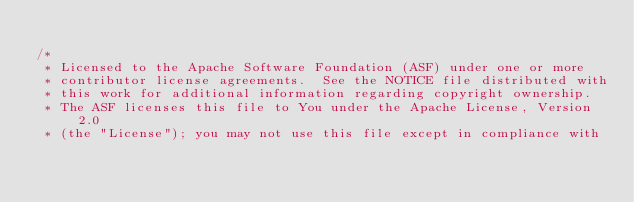<code> <loc_0><loc_0><loc_500><loc_500><_C_>
/*
 * Licensed to the Apache Software Foundation (ASF) under one or more
 * contributor license agreements.  See the NOTICE file distributed with
 * this work for additional information regarding copyright ownership.
 * The ASF licenses this file to You under the Apache License, Version 2.0
 * (the "License"); you may not use this file except in compliance with</code> 